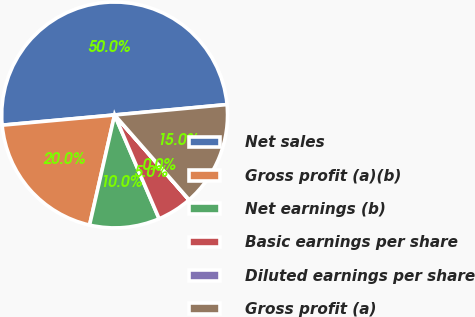Convert chart. <chart><loc_0><loc_0><loc_500><loc_500><pie_chart><fcel>Net sales<fcel>Gross profit (a)(b)<fcel>Net earnings (b)<fcel>Basic earnings per share<fcel>Diluted earnings per share<fcel>Gross profit (a)<nl><fcel>49.97%<fcel>20.0%<fcel>10.01%<fcel>5.01%<fcel>0.01%<fcel>15.0%<nl></chart> 